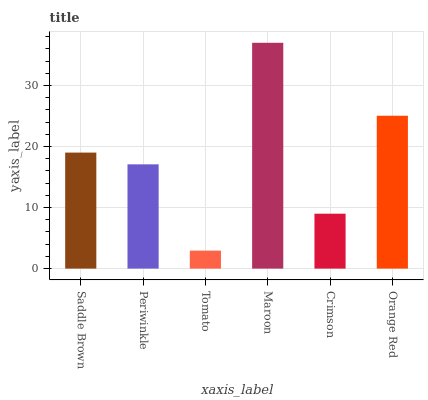Is Tomato the minimum?
Answer yes or no. Yes. Is Maroon the maximum?
Answer yes or no. Yes. Is Periwinkle the minimum?
Answer yes or no. No. Is Periwinkle the maximum?
Answer yes or no. No. Is Saddle Brown greater than Periwinkle?
Answer yes or no. Yes. Is Periwinkle less than Saddle Brown?
Answer yes or no. Yes. Is Periwinkle greater than Saddle Brown?
Answer yes or no. No. Is Saddle Brown less than Periwinkle?
Answer yes or no. No. Is Saddle Brown the high median?
Answer yes or no. Yes. Is Periwinkle the low median?
Answer yes or no. Yes. Is Crimson the high median?
Answer yes or no. No. Is Maroon the low median?
Answer yes or no. No. 